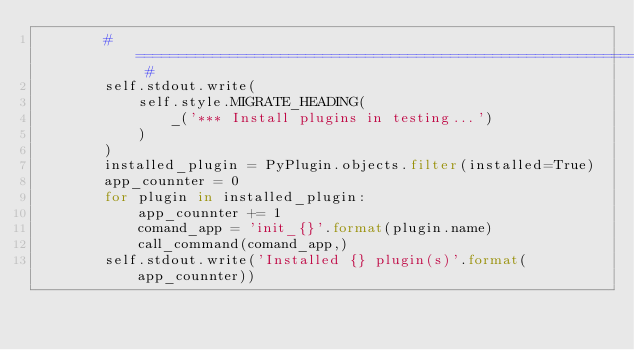Convert code to text. <code><loc_0><loc_0><loc_500><loc_500><_Python_>        # ================================================================== #
        self.stdout.write(
            self.style.MIGRATE_HEADING(
                _('*** Install plugins in testing...')
            )
        )
        installed_plugin = PyPlugin.objects.filter(installed=True)
        app_counnter = 0
        for plugin in installed_plugin:
            app_counnter += 1
            comand_app = 'init_{}'.format(plugin.name)
            call_command(comand_app,)
        self.stdout.write('Installed {} plugin(s)'.format(app_counnter))
</code> 